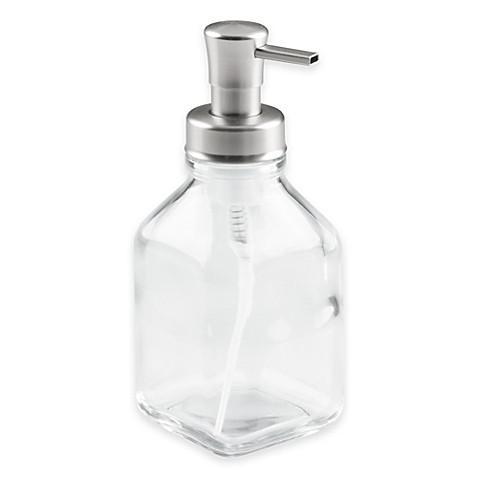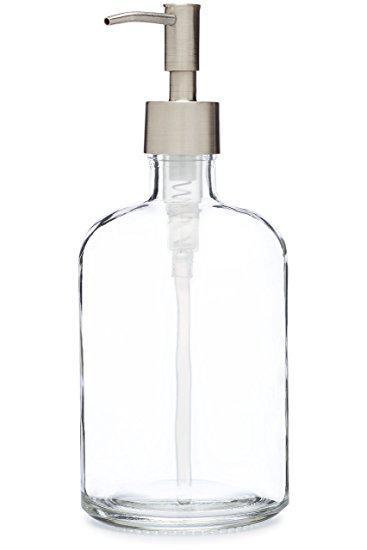The first image is the image on the left, the second image is the image on the right. Assess this claim about the two images: "There are exactly two clear dispensers, one in each image.". Correct or not? Answer yes or no. Yes. The first image is the image on the left, the second image is the image on the right. Examine the images to the left and right. Is the description "The left image features a caddy that holds two dispenser bottles side-by-side, and their pump nozzles face right." accurate? Answer yes or no. No. 